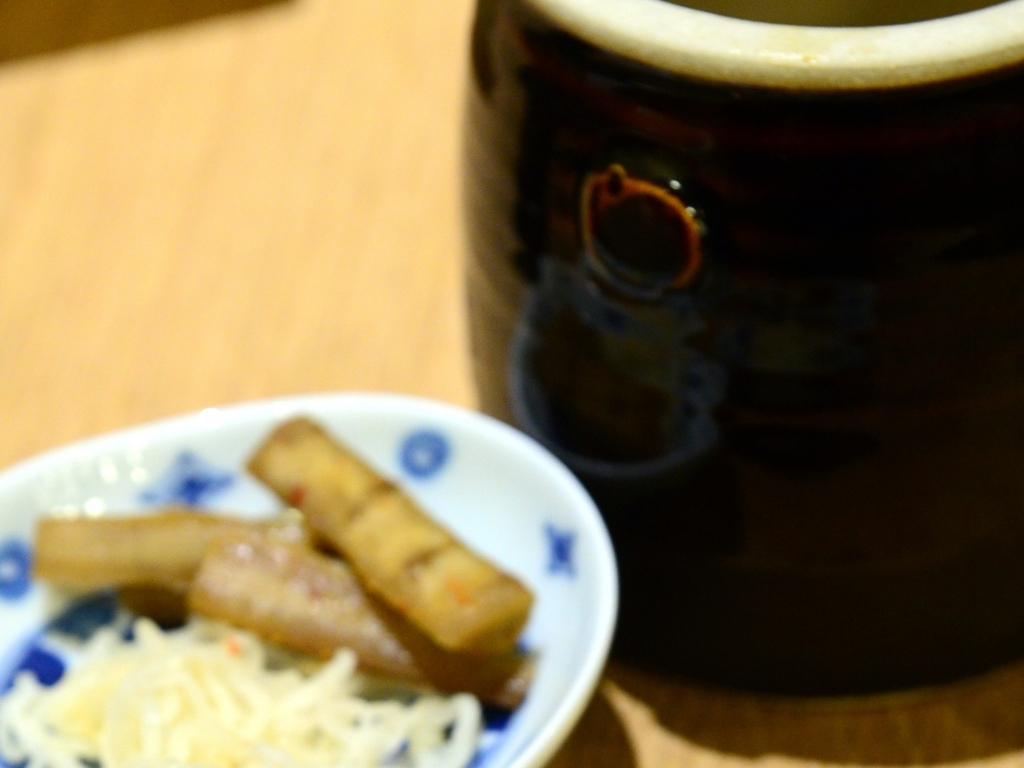Can you describe the composition and elements present in this blurry image? Although the image is not sharply focused, it contains a blurred foreground object that resembles a small bowl with food items, which could be spring rolls. The background features a large pottery vessel, likely a mug or jar. Because of the focus issue, the specific details of the scene are obscured, blending the colors and shapes softly together. 